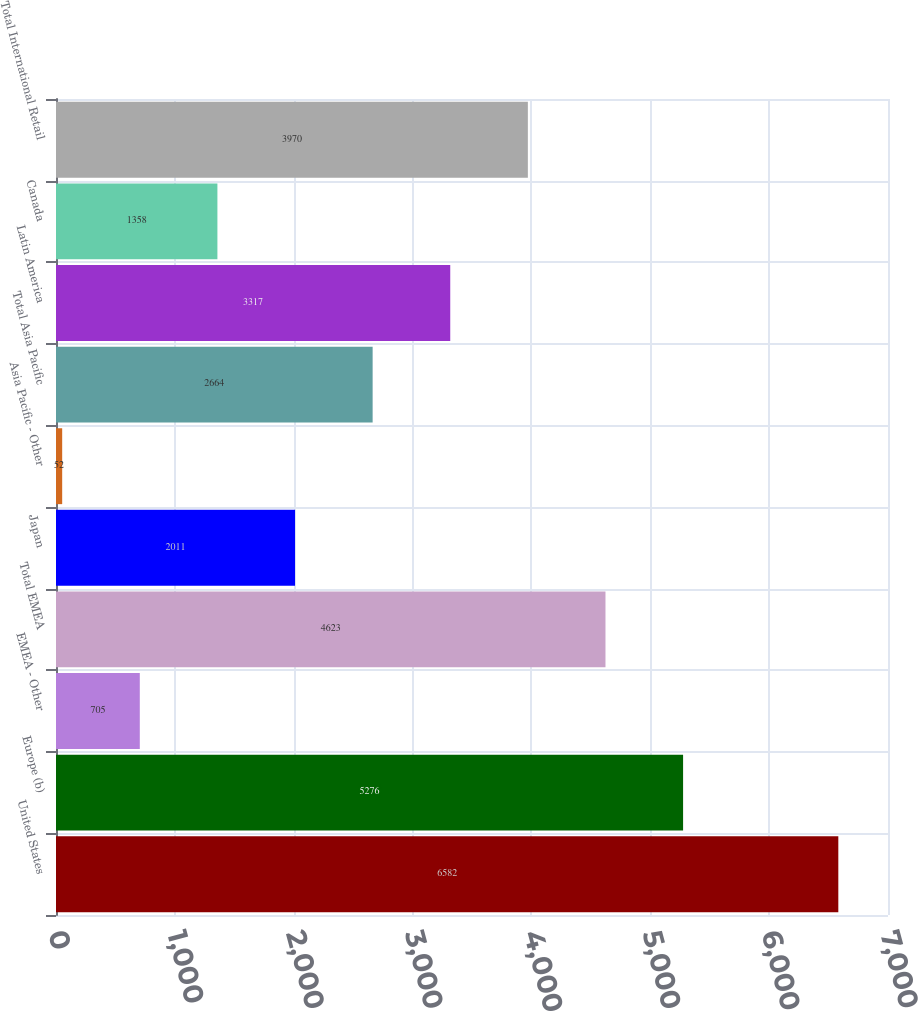Convert chart. <chart><loc_0><loc_0><loc_500><loc_500><bar_chart><fcel>United States<fcel>Europe (b)<fcel>EMEA - Other<fcel>Total EMEA<fcel>Japan<fcel>Asia Pacific - Other<fcel>Total Asia Pacific<fcel>Latin America<fcel>Canada<fcel>Total International Retail<nl><fcel>6582<fcel>5276<fcel>705<fcel>4623<fcel>2011<fcel>52<fcel>2664<fcel>3317<fcel>1358<fcel>3970<nl></chart> 